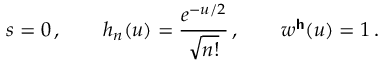Convert formula to latex. <formula><loc_0><loc_0><loc_500><loc_500>s = 0 \, , \quad h _ { n } ( u ) = \frac { e ^ { - u / 2 } } { \sqrt { n ! } } \, , \quad w ^ { h } ( u ) = 1 \, .</formula> 